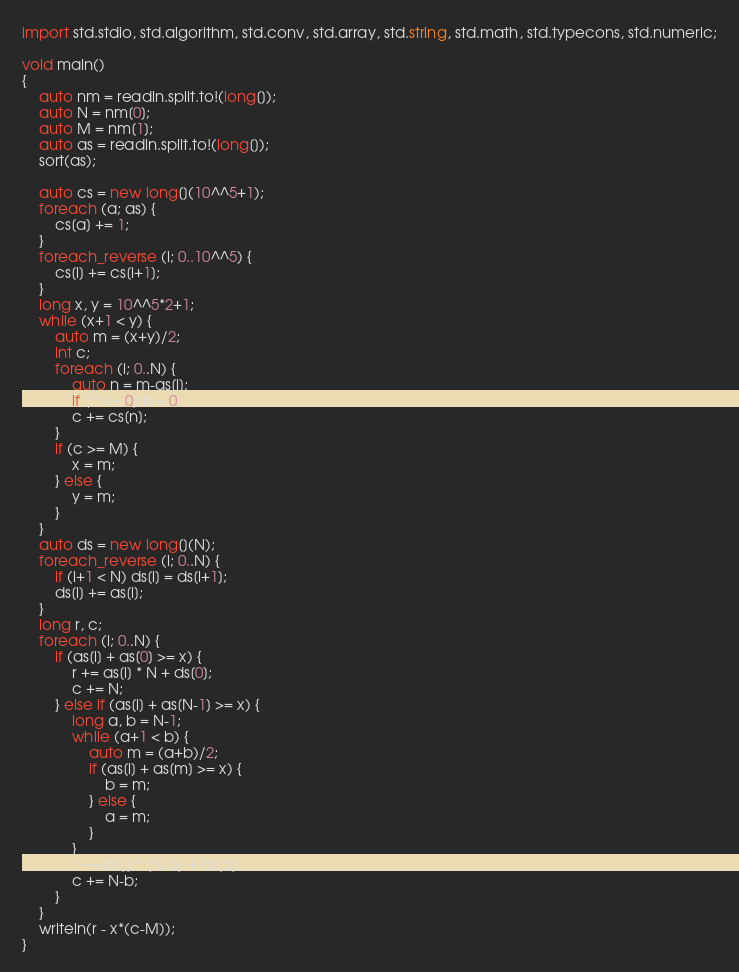<code> <loc_0><loc_0><loc_500><loc_500><_D_>import std.stdio, std.algorithm, std.conv, std.array, std.string, std.math, std.typecons, std.numeric;

void main()
{
    auto nm = readln.split.to!(long[]);
    auto N = nm[0];
    auto M = nm[1];
    auto as = readln.split.to!(long[]);
    sort(as);

    auto cs = new long[](10^^5+1);
    foreach (a; as) {
        cs[a] += 1;
    }
    foreach_reverse (i; 0..10^^5) {
        cs[i] += cs[i+1];
    }
    long x, y = 10^^5*2+1;
    while (x+1 < y) {
        auto m = (x+y)/2;
        int c;
        foreach (i; 0..N) {
            auto n = m-as[i];
            if (n <= 0) n = 0;
            c += cs[n];
        }
        if (c >= M) {
            x = m;
        } else {
            y = m;
        }
    }
    auto ds = new long[](N);
    foreach_reverse (i; 0..N) {
        if (i+1 < N) ds[i] = ds[i+1];
        ds[i] += as[i];
    }
    long r, c;
    foreach (i; 0..N) {
        if (as[i] + as[0] >= x) {
            r += as[i] * N + ds[0];
            c += N;
        } else if (as[i] + as[N-1] >= x) {
            long a, b = N-1;
            while (a+1 < b) {
                auto m = (a+b)/2;
                if (as[i] + as[m] >= x) {
                    b = m;
                } else {
                    a = m;
                }
            }
            r += as[i] * (N-b) + ds[b];
            c += N-b;
        }
    }
    writeln(r - x*(c-M));
}</code> 